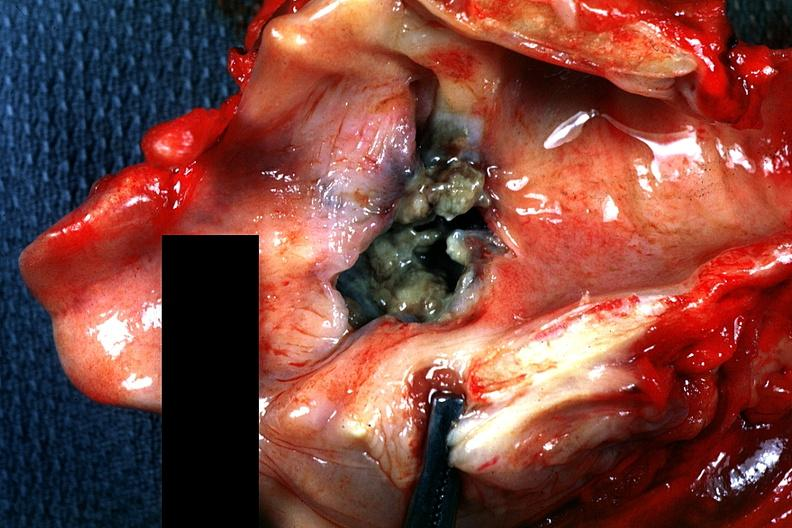does this image show large ulcerated and necrotic appearing lesion?
Answer the question using a single word or phrase. Yes 